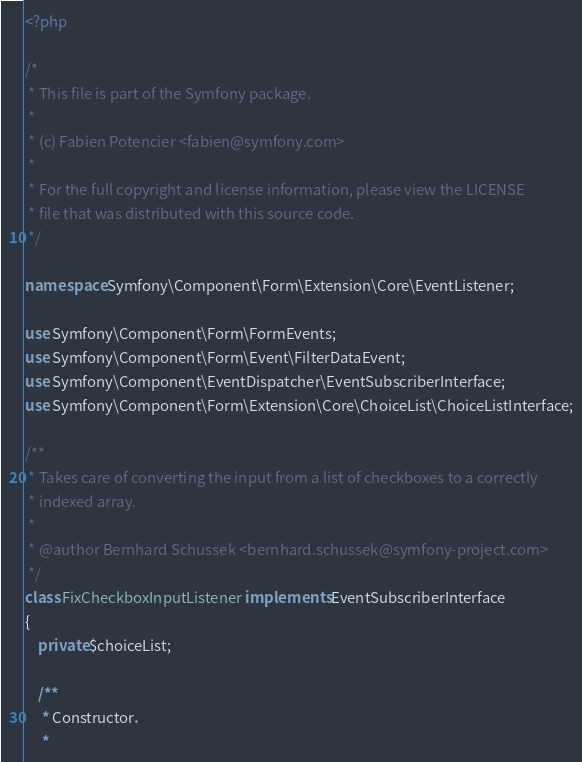<code> <loc_0><loc_0><loc_500><loc_500><_PHP_><?php

/*
 * This file is part of the Symfony package.
 *
 * (c) Fabien Potencier <fabien@symfony.com>
 *
 * For the full copyright and license information, please view the LICENSE
 * file that was distributed with this source code.
 */

namespace Symfony\Component\Form\Extension\Core\EventListener;

use Symfony\Component\Form\FormEvents;
use Symfony\Component\Form\Event\FilterDataEvent;
use Symfony\Component\EventDispatcher\EventSubscriberInterface;
use Symfony\Component\Form\Extension\Core\ChoiceList\ChoiceListInterface;

/**
 * Takes care of converting the input from a list of checkboxes to a correctly
 * indexed array.
 *
 * @author Bernhard Schussek <bernhard.schussek@symfony-project.com>
 */
class FixCheckboxInputListener implements EventSubscriberInterface
{
    private $choiceList;

    /**
     * Constructor.
     *</code> 